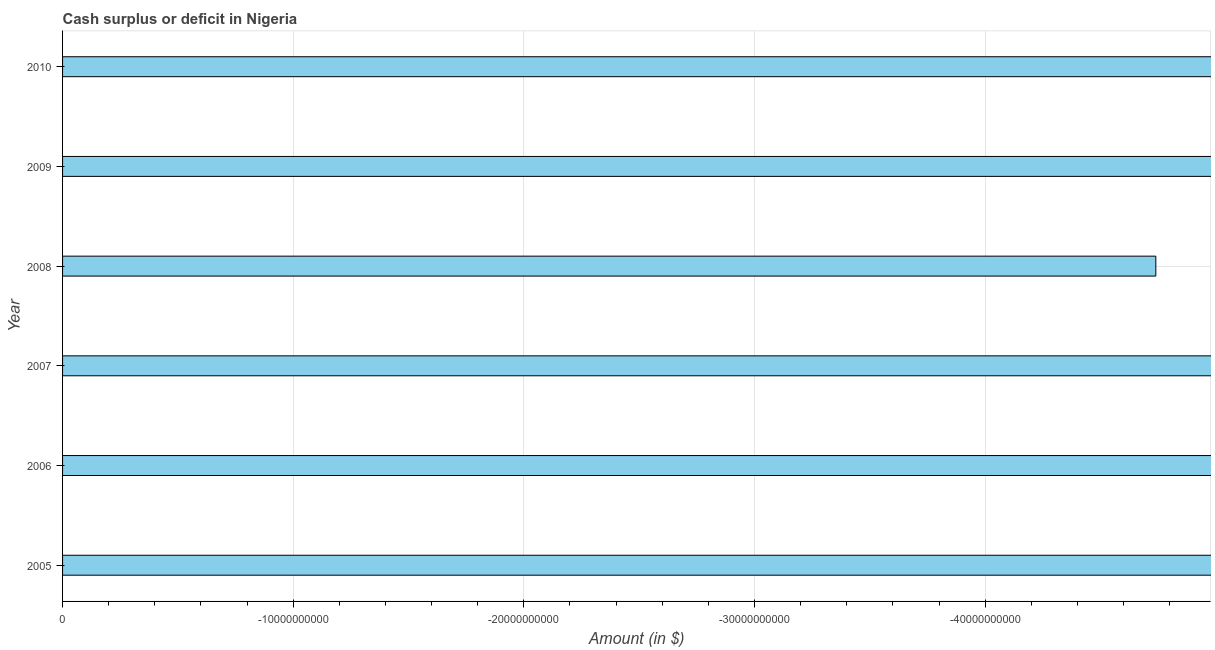What is the title of the graph?
Offer a very short reply. Cash surplus or deficit in Nigeria. What is the label or title of the X-axis?
Provide a short and direct response. Amount (in $). In how many years, is the cash surplus or deficit greater than -34000000000 $?
Your answer should be compact. 0. In how many years, is the cash surplus or deficit greater than the average cash surplus or deficit taken over all years?
Provide a short and direct response. 0. How many bars are there?
Provide a succinct answer. 0. What is the difference between two consecutive major ticks on the X-axis?
Your answer should be very brief. 1.00e+1. Are the values on the major ticks of X-axis written in scientific E-notation?
Provide a short and direct response. No. What is the Amount (in $) of 2005?
Keep it short and to the point. 0. What is the Amount (in $) in 2006?
Your answer should be compact. 0. What is the Amount (in $) of 2008?
Make the answer very short. 0. What is the Amount (in $) of 2009?
Your answer should be very brief. 0. 